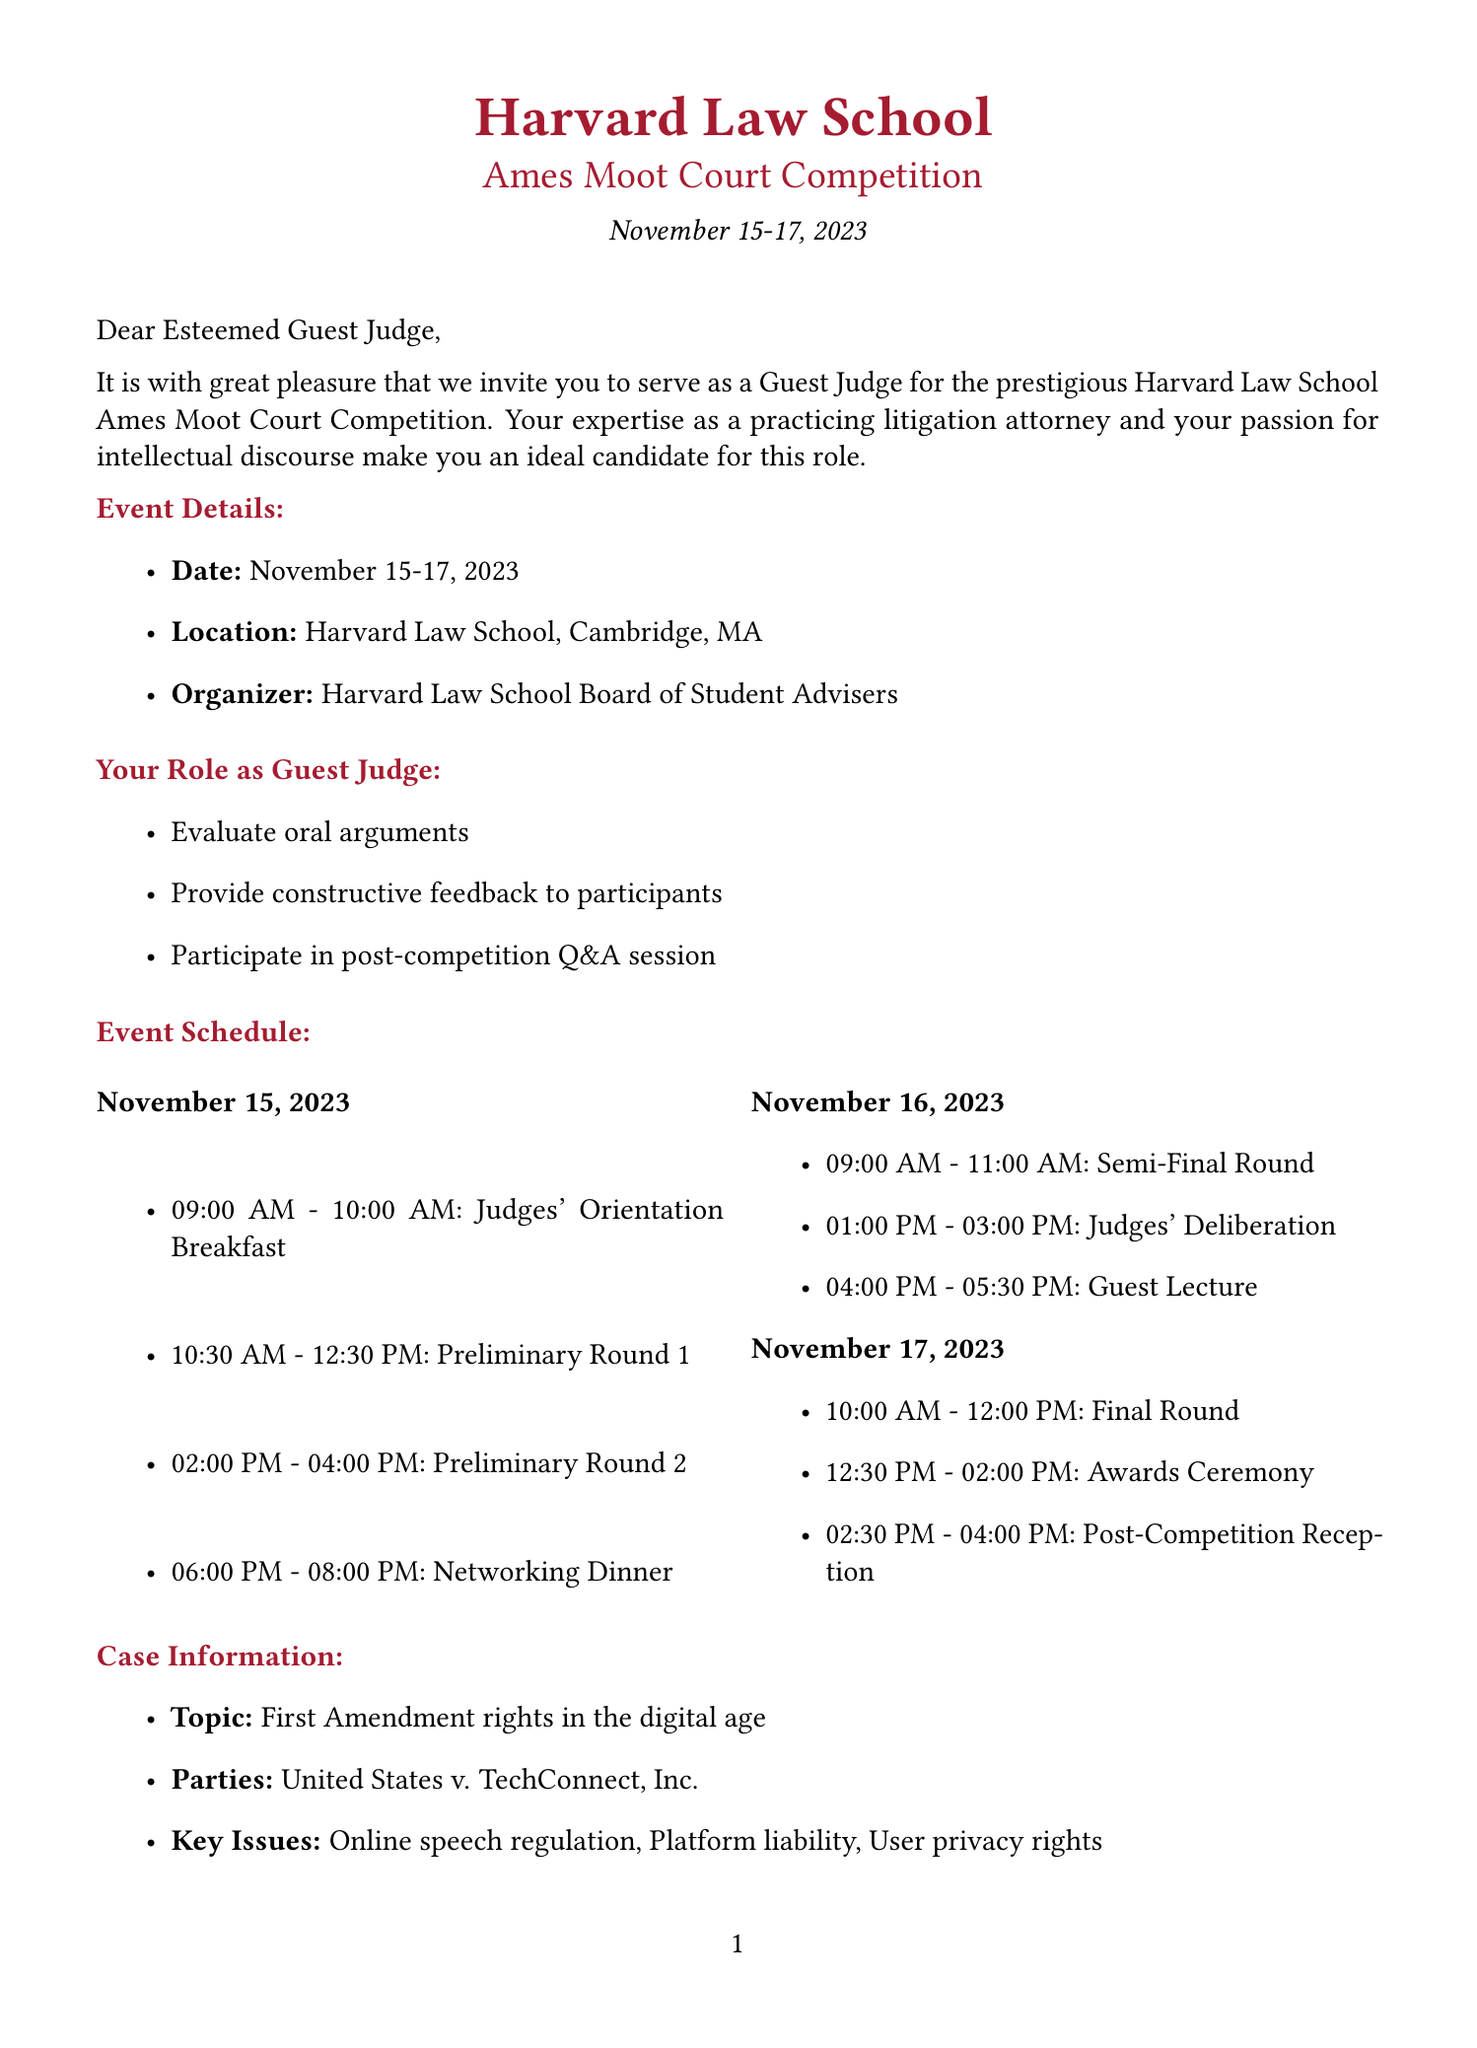What is the name of the event? The name of the event is stated in the document as the "Harvard Law School Ames Moot Court Competition."
Answer: Harvard Law School Ames Moot Court Competition What are the dates of the competition? The document specifies that the competition happens on November 15-17, 2023.
Answer: November 15-17, 2023 Who is the contact person for the event? The contact person is identified by their name and title in the document, which is Professor Emma Walton, Faculty Advisor.
Answer: Professor Emma Walton What is the dress code for the event? The document outlines the dress code and specifies it as "Professional attire (suit and tie for men, equivalent for women)."
Answer: Professional attire (suit and tie for men, equivalent for women) What role will the invitee play in the event? The letter states that the invitee's role is to serve as Guest Judge, which involves several responsibilities.
Answer: Guest Judge What is the topic of the case for the moot court? The document provides information about the case topic, which is "First Amendment rights in the digital age."
Answer: First Amendment rights in the digital age During which round will the judges' deliberation take place? The schedule indicates that judges' deliberation will occur on November 16, 2023, from 1:00 PM to 3:00 PM.
Answer: November 16, 2023 What is one of the key issues for the case? The document lists key issues, and "Online speech regulation" is one of them.
Answer: Online speech regulation What hotel will accommodate the guest judges? The document specifies that The Charles Hotel in Cambridge will accommodate the guest judges during the event.
Answer: The Charles Hotel, Cambridge 